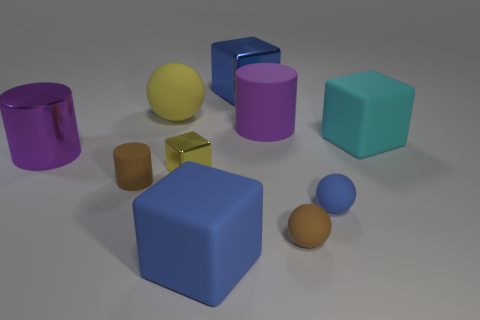There is a yellow thing that is the same size as the blue metallic object; what material is it?
Make the answer very short. Rubber. Is there another tiny brown sphere that has the same material as the small brown sphere?
Keep it short and to the point. No. Is the number of big purple cylinders to the left of the tiny yellow shiny thing less than the number of blue metallic cubes?
Offer a terse response. No. The large purple cylinder right of the big purple object on the left side of the brown cylinder is made of what material?
Keep it short and to the point. Rubber. There is a large rubber object that is both on the left side of the blue metallic block and in front of the big matte sphere; what is its shape?
Provide a succinct answer. Cube. What number of other things are there of the same color as the big metal cylinder?
Your answer should be compact. 1. How many objects are either matte cylinders that are in front of the cyan rubber object or cyan things?
Offer a very short reply. 2. There is a small shiny cube; is it the same color as the big matte cube that is right of the blue matte ball?
Offer a terse response. No. Are there any other things that have the same size as the yellow matte sphere?
Give a very brief answer. Yes. What is the size of the brown rubber object to the right of the brown rubber object that is to the left of the big blue matte object?
Ensure brevity in your answer.  Small. 